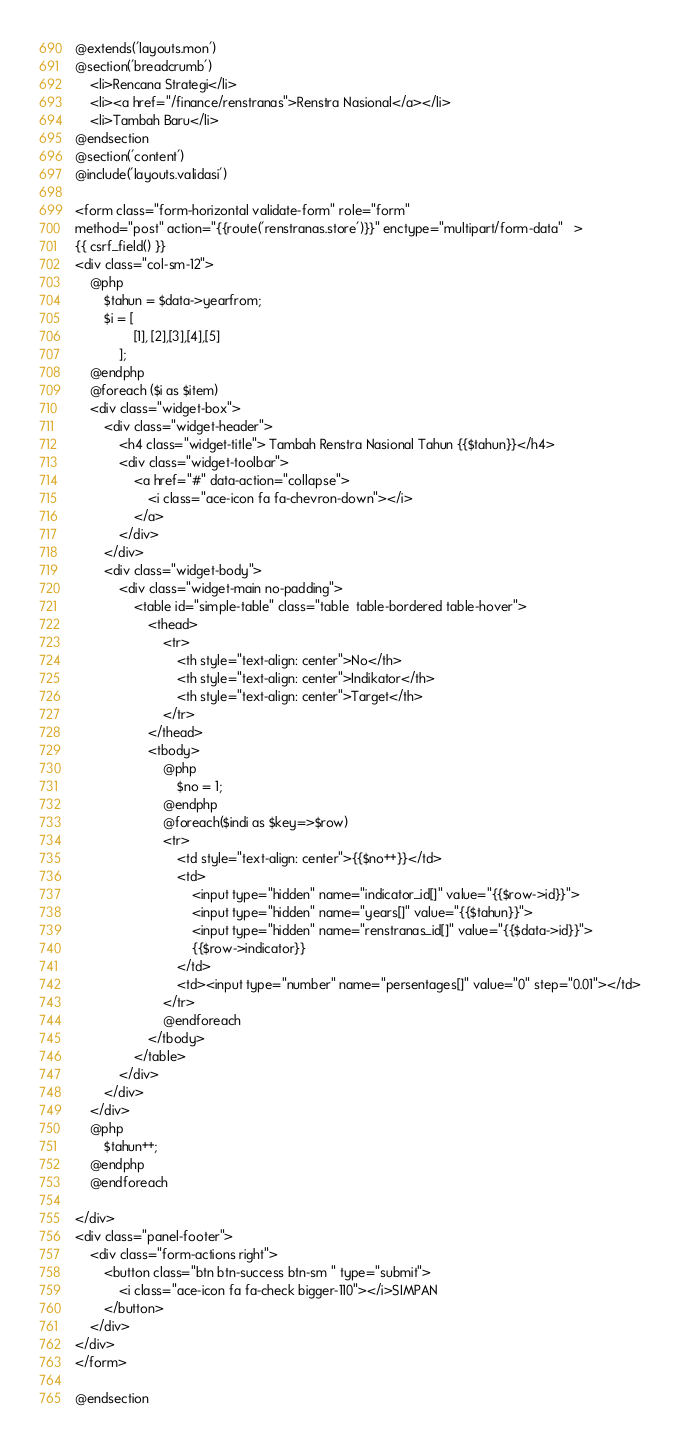<code> <loc_0><loc_0><loc_500><loc_500><_PHP_>@extends('layouts.mon')
@section('breadcrumb')
    <li>Rencana Strategi</li>
    <li><a href="/finance/renstranas">Renstra Nasional</a></li>
    <li>Tambah Baru</li>
@endsection
@section('content')
@include('layouts.validasi')

<form class="form-horizontal validate-form" role="form" 
method="post" action="{{route('renstranas.store')}}" enctype="multipart/form-data"   >
{{ csrf_field() }}
<div class="col-sm-12">
    @php
        $tahun = $data->yearfrom;
        $i = [
                [1], [2],[3],[4],[5]
            ];
    @endphp
    @foreach ($i as $item)
    <div class="widget-box">
        <div class="widget-header">
            <h4 class="widget-title"> Tambah Renstra Nasional Tahun {{$tahun}}</h4>
            <div class="widget-toolbar">
                <a href="#" data-action="collapse">
                    <i class="ace-icon fa fa-chevron-down"></i>
                </a>
            </div>
        </div>
        <div class="widget-body">
            <div class="widget-main no-padding">  
                <table id="simple-table" class="table  table-bordered table-hover">
                    <thead>
                        <tr>
                            <th style="text-align: center">No</th>
                            <th style="text-align: center">Indikator</th>
                            <th style="text-align: center">Target</th>
                        </tr>
                    </thead>
                    <tbody>
                        @php
                            $no = 1;
                        @endphp
                        @foreach($indi as $key=>$row)
                        <tr>
                            <td style="text-align: center">{{$no++}}</td>
                            <td>
                                <input type="hidden" name="indicator_id[]" value="{{$row->id}}">
                                <input type="hidden" name="years[]" value="{{$tahun}}">
                                <input type="hidden" name="renstranas_id[]" value="{{$data->id}}">
                                {{$row->indicator}}
                            </td>
                            <td><input type="number" name="persentages[]" value="0" step="0.01"></td>
                        </tr>
                        @endforeach
                    </tbody>
                </table>   
            </div>  
        </div>
    </div>
    @php
        $tahun++;
    @endphp
    @endforeach
    
</div>
<div class="panel-footer">
    <div class="form-actions right">
        <button class="btn btn-success btn-sm " type="submit">
            <i class="ace-icon fa fa-check bigger-110"></i>SIMPAN
        </button>
    </div>
</div>
</form>

@endsection</code> 